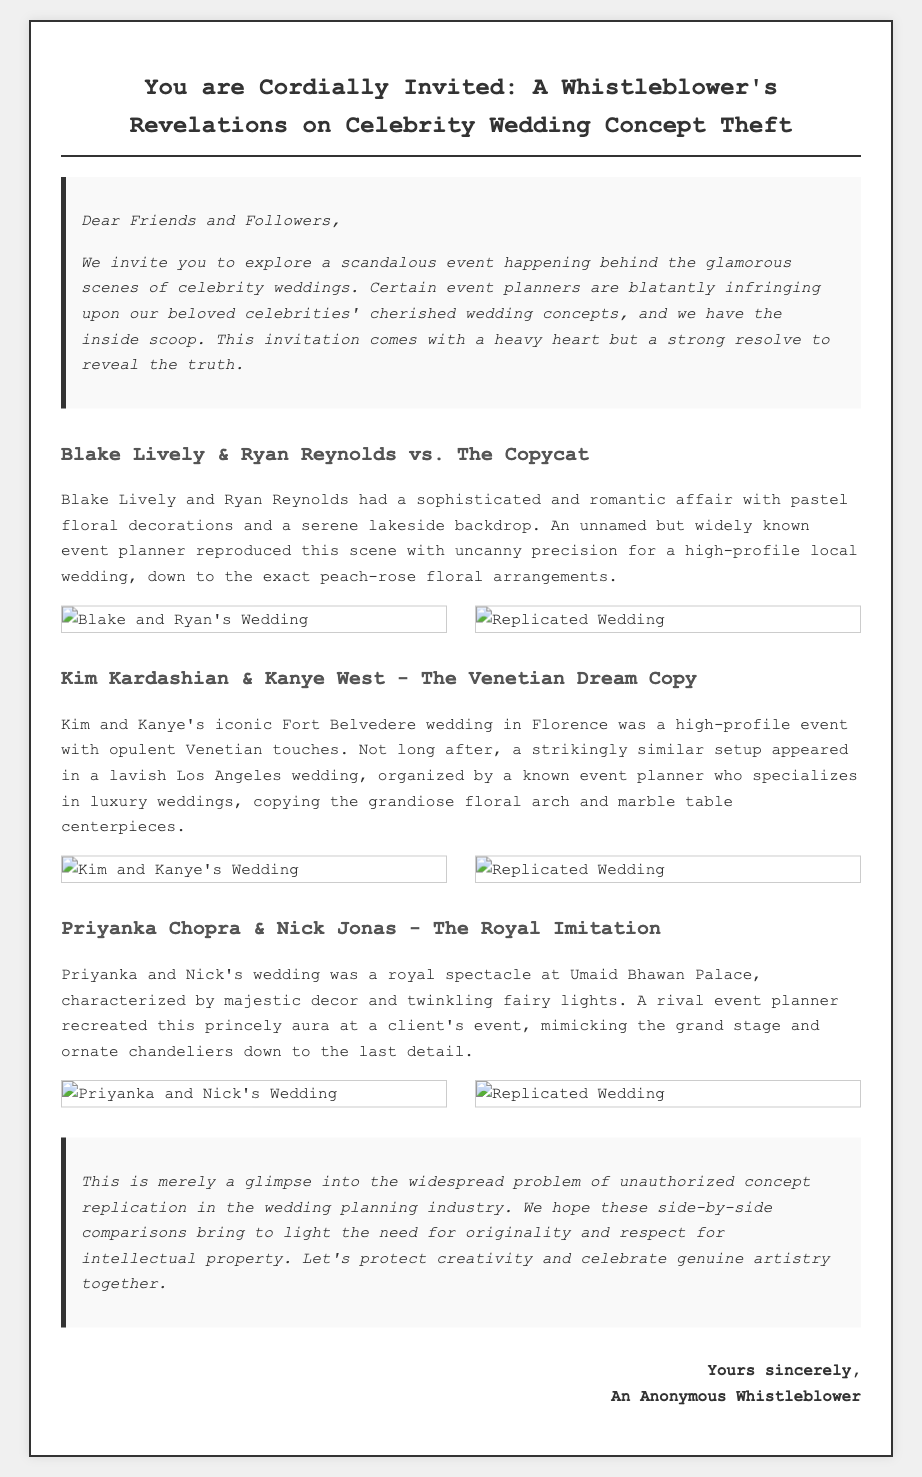What is the primary theme of the invitation? The primary theme of the invitation is unauthorized copying of celebrity wedding concepts by event planners.
Answer: Unauthorized copying Who are the celebrities featured in the first comparison? The first comparison showcases Blake Lively and Ryan Reynolds.
Answer: Blake Lively and Ryan Reynolds What event is being replicated in the second section? The second section details the replication of Kim Kardashian and Kanye West's wedding.
Answer: Kim Kardashian and Kanye West's wedding What aspect of Priyanka and Nick's wedding was replicated? The replication includes the grand stage and ornate chandeliers from their wedding.
Answer: Grand stage and ornate chandeliers How many celebrity weddings are discussed in the invitation? The invitation discusses three celebrity weddings.
Answer: Three What type of decor was featured in Blake Lively and Ryan Reynolds' wedding? The decor featured pastel floral decorations with a serene lakeside backdrop.
Answer: Pastel floral decorations Which event planner type is mentioned in relation to copying weddings? A known event planner who specializes in luxury weddings is mentioned.
Answer: Luxury weddings Which design element was common in both Kim and Kanye's and the replicated wedding? The grand floral arch was a common design element.
Answer: Grand floral arch What should the audience protect, according to the closing? The audience should protect originality and respect for intellectual property.
Answer: Originality and respect for intellectual property 